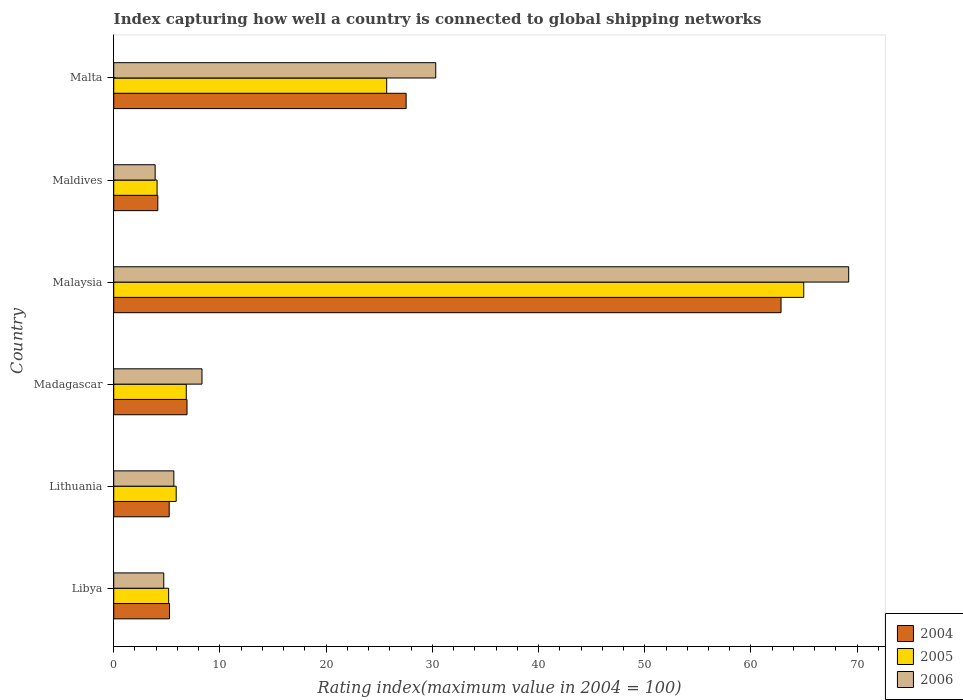Are the number of bars per tick equal to the number of legend labels?
Keep it short and to the point. Yes. Are the number of bars on each tick of the Y-axis equal?
Make the answer very short. Yes. How many bars are there on the 5th tick from the top?
Your answer should be very brief. 3. What is the label of the 2nd group of bars from the top?
Offer a very short reply. Maldives. In how many cases, is the number of bars for a given country not equal to the number of legend labels?
Offer a very short reply. 0. What is the rating index in 2005 in Malaysia?
Provide a succinct answer. 64.97. Across all countries, what is the maximum rating index in 2005?
Your response must be concise. 64.97. In which country was the rating index in 2006 maximum?
Give a very brief answer. Malaysia. In which country was the rating index in 2006 minimum?
Offer a terse response. Maldives. What is the total rating index in 2004 in the graph?
Keep it short and to the point. 111.88. What is the difference between the rating index in 2006 in Madagascar and that in Malta?
Your answer should be very brief. -22.01. What is the difference between the rating index in 2005 in Maldives and the rating index in 2004 in Madagascar?
Offer a terse response. -2.82. What is the average rating index in 2005 per country?
Keep it short and to the point. 18.77. What is the difference between the rating index in 2005 and rating index in 2004 in Maldives?
Provide a succinct answer. -0.07. What is the ratio of the rating index in 2006 in Libya to that in Lithuania?
Give a very brief answer. 0.83. What is the difference between the highest and the second highest rating index in 2004?
Your answer should be very brief. 35.3. What is the difference between the highest and the lowest rating index in 2005?
Keep it short and to the point. 60.89. In how many countries, is the rating index in 2005 greater than the average rating index in 2005 taken over all countries?
Your answer should be compact. 2. What does the 2nd bar from the top in Lithuania represents?
Offer a terse response. 2005. What does the 2nd bar from the bottom in Maldives represents?
Ensure brevity in your answer.  2005. Is it the case that in every country, the sum of the rating index in 2004 and rating index in 2006 is greater than the rating index in 2005?
Offer a terse response. Yes. Are the values on the major ticks of X-axis written in scientific E-notation?
Provide a short and direct response. No. Does the graph contain any zero values?
Provide a succinct answer. No. How are the legend labels stacked?
Keep it short and to the point. Vertical. What is the title of the graph?
Provide a short and direct response. Index capturing how well a country is connected to global shipping networks. What is the label or title of the X-axis?
Provide a succinct answer. Rating index(maximum value in 2004 = 100). What is the Rating index(maximum value in 2004 = 100) in 2004 in Libya?
Your answer should be very brief. 5.25. What is the Rating index(maximum value in 2004 = 100) of 2005 in Libya?
Your answer should be compact. 5.17. What is the Rating index(maximum value in 2004 = 100) in 2006 in Libya?
Offer a terse response. 4.71. What is the Rating index(maximum value in 2004 = 100) of 2004 in Lithuania?
Make the answer very short. 5.22. What is the Rating index(maximum value in 2004 = 100) in 2005 in Lithuania?
Make the answer very short. 5.88. What is the Rating index(maximum value in 2004 = 100) of 2006 in Lithuania?
Ensure brevity in your answer.  5.66. What is the Rating index(maximum value in 2004 = 100) in 2005 in Madagascar?
Ensure brevity in your answer.  6.83. What is the Rating index(maximum value in 2004 = 100) in 2006 in Madagascar?
Keep it short and to the point. 8.31. What is the Rating index(maximum value in 2004 = 100) of 2004 in Malaysia?
Make the answer very short. 62.83. What is the Rating index(maximum value in 2004 = 100) in 2005 in Malaysia?
Give a very brief answer. 64.97. What is the Rating index(maximum value in 2004 = 100) of 2006 in Malaysia?
Provide a short and direct response. 69.2. What is the Rating index(maximum value in 2004 = 100) in 2004 in Maldives?
Keep it short and to the point. 4.15. What is the Rating index(maximum value in 2004 = 100) in 2005 in Maldives?
Provide a short and direct response. 4.08. What is the Rating index(maximum value in 2004 = 100) of 2004 in Malta?
Offer a terse response. 27.53. What is the Rating index(maximum value in 2004 = 100) of 2005 in Malta?
Offer a terse response. 25.7. What is the Rating index(maximum value in 2004 = 100) in 2006 in Malta?
Your response must be concise. 30.32. Across all countries, what is the maximum Rating index(maximum value in 2004 = 100) in 2004?
Make the answer very short. 62.83. Across all countries, what is the maximum Rating index(maximum value in 2004 = 100) of 2005?
Ensure brevity in your answer.  64.97. Across all countries, what is the maximum Rating index(maximum value in 2004 = 100) of 2006?
Provide a succinct answer. 69.2. Across all countries, what is the minimum Rating index(maximum value in 2004 = 100) of 2004?
Make the answer very short. 4.15. Across all countries, what is the minimum Rating index(maximum value in 2004 = 100) in 2005?
Offer a terse response. 4.08. What is the total Rating index(maximum value in 2004 = 100) in 2004 in the graph?
Offer a very short reply. 111.88. What is the total Rating index(maximum value in 2004 = 100) of 2005 in the graph?
Make the answer very short. 112.63. What is the total Rating index(maximum value in 2004 = 100) in 2006 in the graph?
Offer a terse response. 122.1. What is the difference between the Rating index(maximum value in 2004 = 100) of 2004 in Libya and that in Lithuania?
Offer a terse response. 0.03. What is the difference between the Rating index(maximum value in 2004 = 100) of 2005 in Libya and that in Lithuania?
Your answer should be very brief. -0.71. What is the difference between the Rating index(maximum value in 2004 = 100) of 2006 in Libya and that in Lithuania?
Provide a succinct answer. -0.95. What is the difference between the Rating index(maximum value in 2004 = 100) in 2004 in Libya and that in Madagascar?
Provide a succinct answer. -1.65. What is the difference between the Rating index(maximum value in 2004 = 100) of 2005 in Libya and that in Madagascar?
Provide a succinct answer. -1.66. What is the difference between the Rating index(maximum value in 2004 = 100) in 2004 in Libya and that in Malaysia?
Give a very brief answer. -57.58. What is the difference between the Rating index(maximum value in 2004 = 100) of 2005 in Libya and that in Malaysia?
Keep it short and to the point. -59.8. What is the difference between the Rating index(maximum value in 2004 = 100) in 2006 in Libya and that in Malaysia?
Ensure brevity in your answer.  -64.49. What is the difference between the Rating index(maximum value in 2004 = 100) of 2005 in Libya and that in Maldives?
Ensure brevity in your answer.  1.09. What is the difference between the Rating index(maximum value in 2004 = 100) of 2006 in Libya and that in Maldives?
Make the answer very short. 0.81. What is the difference between the Rating index(maximum value in 2004 = 100) of 2004 in Libya and that in Malta?
Keep it short and to the point. -22.28. What is the difference between the Rating index(maximum value in 2004 = 100) of 2005 in Libya and that in Malta?
Ensure brevity in your answer.  -20.53. What is the difference between the Rating index(maximum value in 2004 = 100) of 2006 in Libya and that in Malta?
Keep it short and to the point. -25.61. What is the difference between the Rating index(maximum value in 2004 = 100) of 2004 in Lithuania and that in Madagascar?
Provide a short and direct response. -1.68. What is the difference between the Rating index(maximum value in 2004 = 100) in 2005 in Lithuania and that in Madagascar?
Your answer should be very brief. -0.95. What is the difference between the Rating index(maximum value in 2004 = 100) of 2006 in Lithuania and that in Madagascar?
Offer a very short reply. -2.65. What is the difference between the Rating index(maximum value in 2004 = 100) in 2004 in Lithuania and that in Malaysia?
Offer a very short reply. -57.61. What is the difference between the Rating index(maximum value in 2004 = 100) of 2005 in Lithuania and that in Malaysia?
Your answer should be very brief. -59.09. What is the difference between the Rating index(maximum value in 2004 = 100) in 2006 in Lithuania and that in Malaysia?
Offer a very short reply. -63.54. What is the difference between the Rating index(maximum value in 2004 = 100) in 2004 in Lithuania and that in Maldives?
Offer a terse response. 1.07. What is the difference between the Rating index(maximum value in 2004 = 100) in 2006 in Lithuania and that in Maldives?
Provide a succinct answer. 1.76. What is the difference between the Rating index(maximum value in 2004 = 100) in 2004 in Lithuania and that in Malta?
Ensure brevity in your answer.  -22.31. What is the difference between the Rating index(maximum value in 2004 = 100) in 2005 in Lithuania and that in Malta?
Offer a very short reply. -19.82. What is the difference between the Rating index(maximum value in 2004 = 100) of 2006 in Lithuania and that in Malta?
Give a very brief answer. -24.66. What is the difference between the Rating index(maximum value in 2004 = 100) of 2004 in Madagascar and that in Malaysia?
Give a very brief answer. -55.93. What is the difference between the Rating index(maximum value in 2004 = 100) of 2005 in Madagascar and that in Malaysia?
Keep it short and to the point. -58.14. What is the difference between the Rating index(maximum value in 2004 = 100) of 2006 in Madagascar and that in Malaysia?
Ensure brevity in your answer.  -60.89. What is the difference between the Rating index(maximum value in 2004 = 100) in 2004 in Madagascar and that in Maldives?
Keep it short and to the point. 2.75. What is the difference between the Rating index(maximum value in 2004 = 100) in 2005 in Madagascar and that in Maldives?
Offer a very short reply. 2.75. What is the difference between the Rating index(maximum value in 2004 = 100) in 2006 in Madagascar and that in Maldives?
Provide a succinct answer. 4.41. What is the difference between the Rating index(maximum value in 2004 = 100) in 2004 in Madagascar and that in Malta?
Offer a very short reply. -20.63. What is the difference between the Rating index(maximum value in 2004 = 100) of 2005 in Madagascar and that in Malta?
Make the answer very short. -18.87. What is the difference between the Rating index(maximum value in 2004 = 100) of 2006 in Madagascar and that in Malta?
Ensure brevity in your answer.  -22.01. What is the difference between the Rating index(maximum value in 2004 = 100) of 2004 in Malaysia and that in Maldives?
Ensure brevity in your answer.  58.68. What is the difference between the Rating index(maximum value in 2004 = 100) of 2005 in Malaysia and that in Maldives?
Your answer should be compact. 60.89. What is the difference between the Rating index(maximum value in 2004 = 100) in 2006 in Malaysia and that in Maldives?
Give a very brief answer. 65.3. What is the difference between the Rating index(maximum value in 2004 = 100) in 2004 in Malaysia and that in Malta?
Provide a short and direct response. 35.3. What is the difference between the Rating index(maximum value in 2004 = 100) in 2005 in Malaysia and that in Malta?
Your response must be concise. 39.27. What is the difference between the Rating index(maximum value in 2004 = 100) of 2006 in Malaysia and that in Malta?
Your response must be concise. 38.88. What is the difference between the Rating index(maximum value in 2004 = 100) in 2004 in Maldives and that in Malta?
Your response must be concise. -23.38. What is the difference between the Rating index(maximum value in 2004 = 100) in 2005 in Maldives and that in Malta?
Keep it short and to the point. -21.62. What is the difference between the Rating index(maximum value in 2004 = 100) of 2006 in Maldives and that in Malta?
Your answer should be compact. -26.42. What is the difference between the Rating index(maximum value in 2004 = 100) in 2004 in Libya and the Rating index(maximum value in 2004 = 100) in 2005 in Lithuania?
Provide a succinct answer. -0.63. What is the difference between the Rating index(maximum value in 2004 = 100) in 2004 in Libya and the Rating index(maximum value in 2004 = 100) in 2006 in Lithuania?
Provide a short and direct response. -0.41. What is the difference between the Rating index(maximum value in 2004 = 100) of 2005 in Libya and the Rating index(maximum value in 2004 = 100) of 2006 in Lithuania?
Make the answer very short. -0.49. What is the difference between the Rating index(maximum value in 2004 = 100) in 2004 in Libya and the Rating index(maximum value in 2004 = 100) in 2005 in Madagascar?
Offer a very short reply. -1.58. What is the difference between the Rating index(maximum value in 2004 = 100) of 2004 in Libya and the Rating index(maximum value in 2004 = 100) of 2006 in Madagascar?
Your response must be concise. -3.06. What is the difference between the Rating index(maximum value in 2004 = 100) in 2005 in Libya and the Rating index(maximum value in 2004 = 100) in 2006 in Madagascar?
Ensure brevity in your answer.  -3.14. What is the difference between the Rating index(maximum value in 2004 = 100) of 2004 in Libya and the Rating index(maximum value in 2004 = 100) of 2005 in Malaysia?
Your answer should be compact. -59.72. What is the difference between the Rating index(maximum value in 2004 = 100) in 2004 in Libya and the Rating index(maximum value in 2004 = 100) in 2006 in Malaysia?
Provide a short and direct response. -63.95. What is the difference between the Rating index(maximum value in 2004 = 100) of 2005 in Libya and the Rating index(maximum value in 2004 = 100) of 2006 in Malaysia?
Your answer should be compact. -64.03. What is the difference between the Rating index(maximum value in 2004 = 100) in 2004 in Libya and the Rating index(maximum value in 2004 = 100) in 2005 in Maldives?
Your response must be concise. 1.17. What is the difference between the Rating index(maximum value in 2004 = 100) in 2004 in Libya and the Rating index(maximum value in 2004 = 100) in 2006 in Maldives?
Your response must be concise. 1.35. What is the difference between the Rating index(maximum value in 2004 = 100) in 2005 in Libya and the Rating index(maximum value in 2004 = 100) in 2006 in Maldives?
Keep it short and to the point. 1.27. What is the difference between the Rating index(maximum value in 2004 = 100) in 2004 in Libya and the Rating index(maximum value in 2004 = 100) in 2005 in Malta?
Ensure brevity in your answer.  -20.45. What is the difference between the Rating index(maximum value in 2004 = 100) of 2004 in Libya and the Rating index(maximum value in 2004 = 100) of 2006 in Malta?
Provide a succinct answer. -25.07. What is the difference between the Rating index(maximum value in 2004 = 100) in 2005 in Libya and the Rating index(maximum value in 2004 = 100) in 2006 in Malta?
Provide a succinct answer. -25.15. What is the difference between the Rating index(maximum value in 2004 = 100) in 2004 in Lithuania and the Rating index(maximum value in 2004 = 100) in 2005 in Madagascar?
Offer a very short reply. -1.61. What is the difference between the Rating index(maximum value in 2004 = 100) in 2004 in Lithuania and the Rating index(maximum value in 2004 = 100) in 2006 in Madagascar?
Your answer should be very brief. -3.09. What is the difference between the Rating index(maximum value in 2004 = 100) in 2005 in Lithuania and the Rating index(maximum value in 2004 = 100) in 2006 in Madagascar?
Give a very brief answer. -2.43. What is the difference between the Rating index(maximum value in 2004 = 100) in 2004 in Lithuania and the Rating index(maximum value in 2004 = 100) in 2005 in Malaysia?
Provide a short and direct response. -59.75. What is the difference between the Rating index(maximum value in 2004 = 100) in 2004 in Lithuania and the Rating index(maximum value in 2004 = 100) in 2006 in Malaysia?
Your answer should be compact. -63.98. What is the difference between the Rating index(maximum value in 2004 = 100) in 2005 in Lithuania and the Rating index(maximum value in 2004 = 100) in 2006 in Malaysia?
Offer a terse response. -63.32. What is the difference between the Rating index(maximum value in 2004 = 100) of 2004 in Lithuania and the Rating index(maximum value in 2004 = 100) of 2005 in Maldives?
Offer a very short reply. 1.14. What is the difference between the Rating index(maximum value in 2004 = 100) of 2004 in Lithuania and the Rating index(maximum value in 2004 = 100) of 2006 in Maldives?
Ensure brevity in your answer.  1.32. What is the difference between the Rating index(maximum value in 2004 = 100) of 2005 in Lithuania and the Rating index(maximum value in 2004 = 100) of 2006 in Maldives?
Ensure brevity in your answer.  1.98. What is the difference between the Rating index(maximum value in 2004 = 100) in 2004 in Lithuania and the Rating index(maximum value in 2004 = 100) in 2005 in Malta?
Make the answer very short. -20.48. What is the difference between the Rating index(maximum value in 2004 = 100) of 2004 in Lithuania and the Rating index(maximum value in 2004 = 100) of 2006 in Malta?
Your response must be concise. -25.1. What is the difference between the Rating index(maximum value in 2004 = 100) of 2005 in Lithuania and the Rating index(maximum value in 2004 = 100) of 2006 in Malta?
Give a very brief answer. -24.44. What is the difference between the Rating index(maximum value in 2004 = 100) of 2004 in Madagascar and the Rating index(maximum value in 2004 = 100) of 2005 in Malaysia?
Ensure brevity in your answer.  -58.07. What is the difference between the Rating index(maximum value in 2004 = 100) in 2004 in Madagascar and the Rating index(maximum value in 2004 = 100) in 2006 in Malaysia?
Your response must be concise. -62.3. What is the difference between the Rating index(maximum value in 2004 = 100) of 2005 in Madagascar and the Rating index(maximum value in 2004 = 100) of 2006 in Malaysia?
Provide a short and direct response. -62.37. What is the difference between the Rating index(maximum value in 2004 = 100) in 2004 in Madagascar and the Rating index(maximum value in 2004 = 100) in 2005 in Maldives?
Your answer should be compact. 2.82. What is the difference between the Rating index(maximum value in 2004 = 100) in 2005 in Madagascar and the Rating index(maximum value in 2004 = 100) in 2006 in Maldives?
Your response must be concise. 2.93. What is the difference between the Rating index(maximum value in 2004 = 100) in 2004 in Madagascar and the Rating index(maximum value in 2004 = 100) in 2005 in Malta?
Your answer should be compact. -18.8. What is the difference between the Rating index(maximum value in 2004 = 100) of 2004 in Madagascar and the Rating index(maximum value in 2004 = 100) of 2006 in Malta?
Give a very brief answer. -23.42. What is the difference between the Rating index(maximum value in 2004 = 100) in 2005 in Madagascar and the Rating index(maximum value in 2004 = 100) in 2006 in Malta?
Keep it short and to the point. -23.49. What is the difference between the Rating index(maximum value in 2004 = 100) in 2004 in Malaysia and the Rating index(maximum value in 2004 = 100) in 2005 in Maldives?
Provide a short and direct response. 58.75. What is the difference between the Rating index(maximum value in 2004 = 100) of 2004 in Malaysia and the Rating index(maximum value in 2004 = 100) of 2006 in Maldives?
Provide a short and direct response. 58.93. What is the difference between the Rating index(maximum value in 2004 = 100) of 2005 in Malaysia and the Rating index(maximum value in 2004 = 100) of 2006 in Maldives?
Give a very brief answer. 61.07. What is the difference between the Rating index(maximum value in 2004 = 100) in 2004 in Malaysia and the Rating index(maximum value in 2004 = 100) in 2005 in Malta?
Provide a short and direct response. 37.13. What is the difference between the Rating index(maximum value in 2004 = 100) in 2004 in Malaysia and the Rating index(maximum value in 2004 = 100) in 2006 in Malta?
Give a very brief answer. 32.51. What is the difference between the Rating index(maximum value in 2004 = 100) in 2005 in Malaysia and the Rating index(maximum value in 2004 = 100) in 2006 in Malta?
Your answer should be very brief. 34.65. What is the difference between the Rating index(maximum value in 2004 = 100) of 2004 in Maldives and the Rating index(maximum value in 2004 = 100) of 2005 in Malta?
Provide a succinct answer. -21.55. What is the difference between the Rating index(maximum value in 2004 = 100) of 2004 in Maldives and the Rating index(maximum value in 2004 = 100) of 2006 in Malta?
Make the answer very short. -26.17. What is the difference between the Rating index(maximum value in 2004 = 100) in 2005 in Maldives and the Rating index(maximum value in 2004 = 100) in 2006 in Malta?
Provide a short and direct response. -26.24. What is the average Rating index(maximum value in 2004 = 100) in 2004 per country?
Offer a very short reply. 18.65. What is the average Rating index(maximum value in 2004 = 100) of 2005 per country?
Offer a very short reply. 18.77. What is the average Rating index(maximum value in 2004 = 100) of 2006 per country?
Provide a short and direct response. 20.35. What is the difference between the Rating index(maximum value in 2004 = 100) in 2004 and Rating index(maximum value in 2004 = 100) in 2005 in Libya?
Provide a short and direct response. 0.08. What is the difference between the Rating index(maximum value in 2004 = 100) in 2004 and Rating index(maximum value in 2004 = 100) in 2006 in Libya?
Make the answer very short. 0.54. What is the difference between the Rating index(maximum value in 2004 = 100) in 2005 and Rating index(maximum value in 2004 = 100) in 2006 in Libya?
Your answer should be very brief. 0.46. What is the difference between the Rating index(maximum value in 2004 = 100) in 2004 and Rating index(maximum value in 2004 = 100) in 2005 in Lithuania?
Ensure brevity in your answer.  -0.66. What is the difference between the Rating index(maximum value in 2004 = 100) in 2004 and Rating index(maximum value in 2004 = 100) in 2006 in Lithuania?
Offer a very short reply. -0.44. What is the difference between the Rating index(maximum value in 2004 = 100) in 2005 and Rating index(maximum value in 2004 = 100) in 2006 in Lithuania?
Your answer should be very brief. 0.22. What is the difference between the Rating index(maximum value in 2004 = 100) of 2004 and Rating index(maximum value in 2004 = 100) of 2005 in Madagascar?
Make the answer very short. 0.07. What is the difference between the Rating index(maximum value in 2004 = 100) of 2004 and Rating index(maximum value in 2004 = 100) of 2006 in Madagascar?
Offer a terse response. -1.41. What is the difference between the Rating index(maximum value in 2004 = 100) in 2005 and Rating index(maximum value in 2004 = 100) in 2006 in Madagascar?
Your answer should be very brief. -1.48. What is the difference between the Rating index(maximum value in 2004 = 100) in 2004 and Rating index(maximum value in 2004 = 100) in 2005 in Malaysia?
Provide a short and direct response. -2.14. What is the difference between the Rating index(maximum value in 2004 = 100) in 2004 and Rating index(maximum value in 2004 = 100) in 2006 in Malaysia?
Offer a very short reply. -6.37. What is the difference between the Rating index(maximum value in 2004 = 100) in 2005 and Rating index(maximum value in 2004 = 100) in 2006 in Malaysia?
Your response must be concise. -4.23. What is the difference between the Rating index(maximum value in 2004 = 100) in 2004 and Rating index(maximum value in 2004 = 100) in 2005 in Maldives?
Offer a terse response. 0.07. What is the difference between the Rating index(maximum value in 2004 = 100) of 2005 and Rating index(maximum value in 2004 = 100) of 2006 in Maldives?
Give a very brief answer. 0.18. What is the difference between the Rating index(maximum value in 2004 = 100) of 2004 and Rating index(maximum value in 2004 = 100) of 2005 in Malta?
Offer a terse response. 1.83. What is the difference between the Rating index(maximum value in 2004 = 100) in 2004 and Rating index(maximum value in 2004 = 100) in 2006 in Malta?
Make the answer very short. -2.79. What is the difference between the Rating index(maximum value in 2004 = 100) of 2005 and Rating index(maximum value in 2004 = 100) of 2006 in Malta?
Offer a terse response. -4.62. What is the ratio of the Rating index(maximum value in 2004 = 100) of 2005 in Libya to that in Lithuania?
Your answer should be compact. 0.88. What is the ratio of the Rating index(maximum value in 2004 = 100) of 2006 in Libya to that in Lithuania?
Make the answer very short. 0.83. What is the ratio of the Rating index(maximum value in 2004 = 100) of 2004 in Libya to that in Madagascar?
Your answer should be compact. 0.76. What is the ratio of the Rating index(maximum value in 2004 = 100) of 2005 in Libya to that in Madagascar?
Keep it short and to the point. 0.76. What is the ratio of the Rating index(maximum value in 2004 = 100) of 2006 in Libya to that in Madagascar?
Your response must be concise. 0.57. What is the ratio of the Rating index(maximum value in 2004 = 100) in 2004 in Libya to that in Malaysia?
Provide a succinct answer. 0.08. What is the ratio of the Rating index(maximum value in 2004 = 100) of 2005 in Libya to that in Malaysia?
Provide a short and direct response. 0.08. What is the ratio of the Rating index(maximum value in 2004 = 100) in 2006 in Libya to that in Malaysia?
Give a very brief answer. 0.07. What is the ratio of the Rating index(maximum value in 2004 = 100) of 2004 in Libya to that in Maldives?
Offer a terse response. 1.27. What is the ratio of the Rating index(maximum value in 2004 = 100) in 2005 in Libya to that in Maldives?
Your answer should be compact. 1.27. What is the ratio of the Rating index(maximum value in 2004 = 100) of 2006 in Libya to that in Maldives?
Offer a very short reply. 1.21. What is the ratio of the Rating index(maximum value in 2004 = 100) of 2004 in Libya to that in Malta?
Provide a short and direct response. 0.19. What is the ratio of the Rating index(maximum value in 2004 = 100) in 2005 in Libya to that in Malta?
Offer a terse response. 0.2. What is the ratio of the Rating index(maximum value in 2004 = 100) of 2006 in Libya to that in Malta?
Provide a succinct answer. 0.16. What is the ratio of the Rating index(maximum value in 2004 = 100) in 2004 in Lithuania to that in Madagascar?
Your response must be concise. 0.76. What is the ratio of the Rating index(maximum value in 2004 = 100) in 2005 in Lithuania to that in Madagascar?
Provide a short and direct response. 0.86. What is the ratio of the Rating index(maximum value in 2004 = 100) of 2006 in Lithuania to that in Madagascar?
Your response must be concise. 0.68. What is the ratio of the Rating index(maximum value in 2004 = 100) in 2004 in Lithuania to that in Malaysia?
Offer a very short reply. 0.08. What is the ratio of the Rating index(maximum value in 2004 = 100) of 2005 in Lithuania to that in Malaysia?
Your answer should be compact. 0.09. What is the ratio of the Rating index(maximum value in 2004 = 100) of 2006 in Lithuania to that in Malaysia?
Your answer should be compact. 0.08. What is the ratio of the Rating index(maximum value in 2004 = 100) of 2004 in Lithuania to that in Maldives?
Your response must be concise. 1.26. What is the ratio of the Rating index(maximum value in 2004 = 100) in 2005 in Lithuania to that in Maldives?
Give a very brief answer. 1.44. What is the ratio of the Rating index(maximum value in 2004 = 100) in 2006 in Lithuania to that in Maldives?
Keep it short and to the point. 1.45. What is the ratio of the Rating index(maximum value in 2004 = 100) of 2004 in Lithuania to that in Malta?
Your answer should be very brief. 0.19. What is the ratio of the Rating index(maximum value in 2004 = 100) in 2005 in Lithuania to that in Malta?
Your answer should be very brief. 0.23. What is the ratio of the Rating index(maximum value in 2004 = 100) in 2006 in Lithuania to that in Malta?
Your answer should be very brief. 0.19. What is the ratio of the Rating index(maximum value in 2004 = 100) in 2004 in Madagascar to that in Malaysia?
Your answer should be very brief. 0.11. What is the ratio of the Rating index(maximum value in 2004 = 100) of 2005 in Madagascar to that in Malaysia?
Your answer should be compact. 0.11. What is the ratio of the Rating index(maximum value in 2004 = 100) in 2006 in Madagascar to that in Malaysia?
Offer a very short reply. 0.12. What is the ratio of the Rating index(maximum value in 2004 = 100) of 2004 in Madagascar to that in Maldives?
Ensure brevity in your answer.  1.66. What is the ratio of the Rating index(maximum value in 2004 = 100) of 2005 in Madagascar to that in Maldives?
Keep it short and to the point. 1.67. What is the ratio of the Rating index(maximum value in 2004 = 100) of 2006 in Madagascar to that in Maldives?
Your answer should be compact. 2.13. What is the ratio of the Rating index(maximum value in 2004 = 100) of 2004 in Madagascar to that in Malta?
Offer a terse response. 0.25. What is the ratio of the Rating index(maximum value in 2004 = 100) in 2005 in Madagascar to that in Malta?
Offer a very short reply. 0.27. What is the ratio of the Rating index(maximum value in 2004 = 100) in 2006 in Madagascar to that in Malta?
Keep it short and to the point. 0.27. What is the ratio of the Rating index(maximum value in 2004 = 100) of 2004 in Malaysia to that in Maldives?
Provide a short and direct response. 15.14. What is the ratio of the Rating index(maximum value in 2004 = 100) in 2005 in Malaysia to that in Maldives?
Give a very brief answer. 15.92. What is the ratio of the Rating index(maximum value in 2004 = 100) of 2006 in Malaysia to that in Maldives?
Offer a very short reply. 17.74. What is the ratio of the Rating index(maximum value in 2004 = 100) of 2004 in Malaysia to that in Malta?
Your answer should be very brief. 2.28. What is the ratio of the Rating index(maximum value in 2004 = 100) of 2005 in Malaysia to that in Malta?
Provide a succinct answer. 2.53. What is the ratio of the Rating index(maximum value in 2004 = 100) of 2006 in Malaysia to that in Malta?
Offer a very short reply. 2.28. What is the ratio of the Rating index(maximum value in 2004 = 100) in 2004 in Maldives to that in Malta?
Make the answer very short. 0.15. What is the ratio of the Rating index(maximum value in 2004 = 100) in 2005 in Maldives to that in Malta?
Your answer should be very brief. 0.16. What is the ratio of the Rating index(maximum value in 2004 = 100) in 2006 in Maldives to that in Malta?
Offer a terse response. 0.13. What is the difference between the highest and the second highest Rating index(maximum value in 2004 = 100) of 2004?
Make the answer very short. 35.3. What is the difference between the highest and the second highest Rating index(maximum value in 2004 = 100) in 2005?
Ensure brevity in your answer.  39.27. What is the difference between the highest and the second highest Rating index(maximum value in 2004 = 100) of 2006?
Give a very brief answer. 38.88. What is the difference between the highest and the lowest Rating index(maximum value in 2004 = 100) in 2004?
Make the answer very short. 58.68. What is the difference between the highest and the lowest Rating index(maximum value in 2004 = 100) in 2005?
Offer a very short reply. 60.89. What is the difference between the highest and the lowest Rating index(maximum value in 2004 = 100) in 2006?
Ensure brevity in your answer.  65.3. 